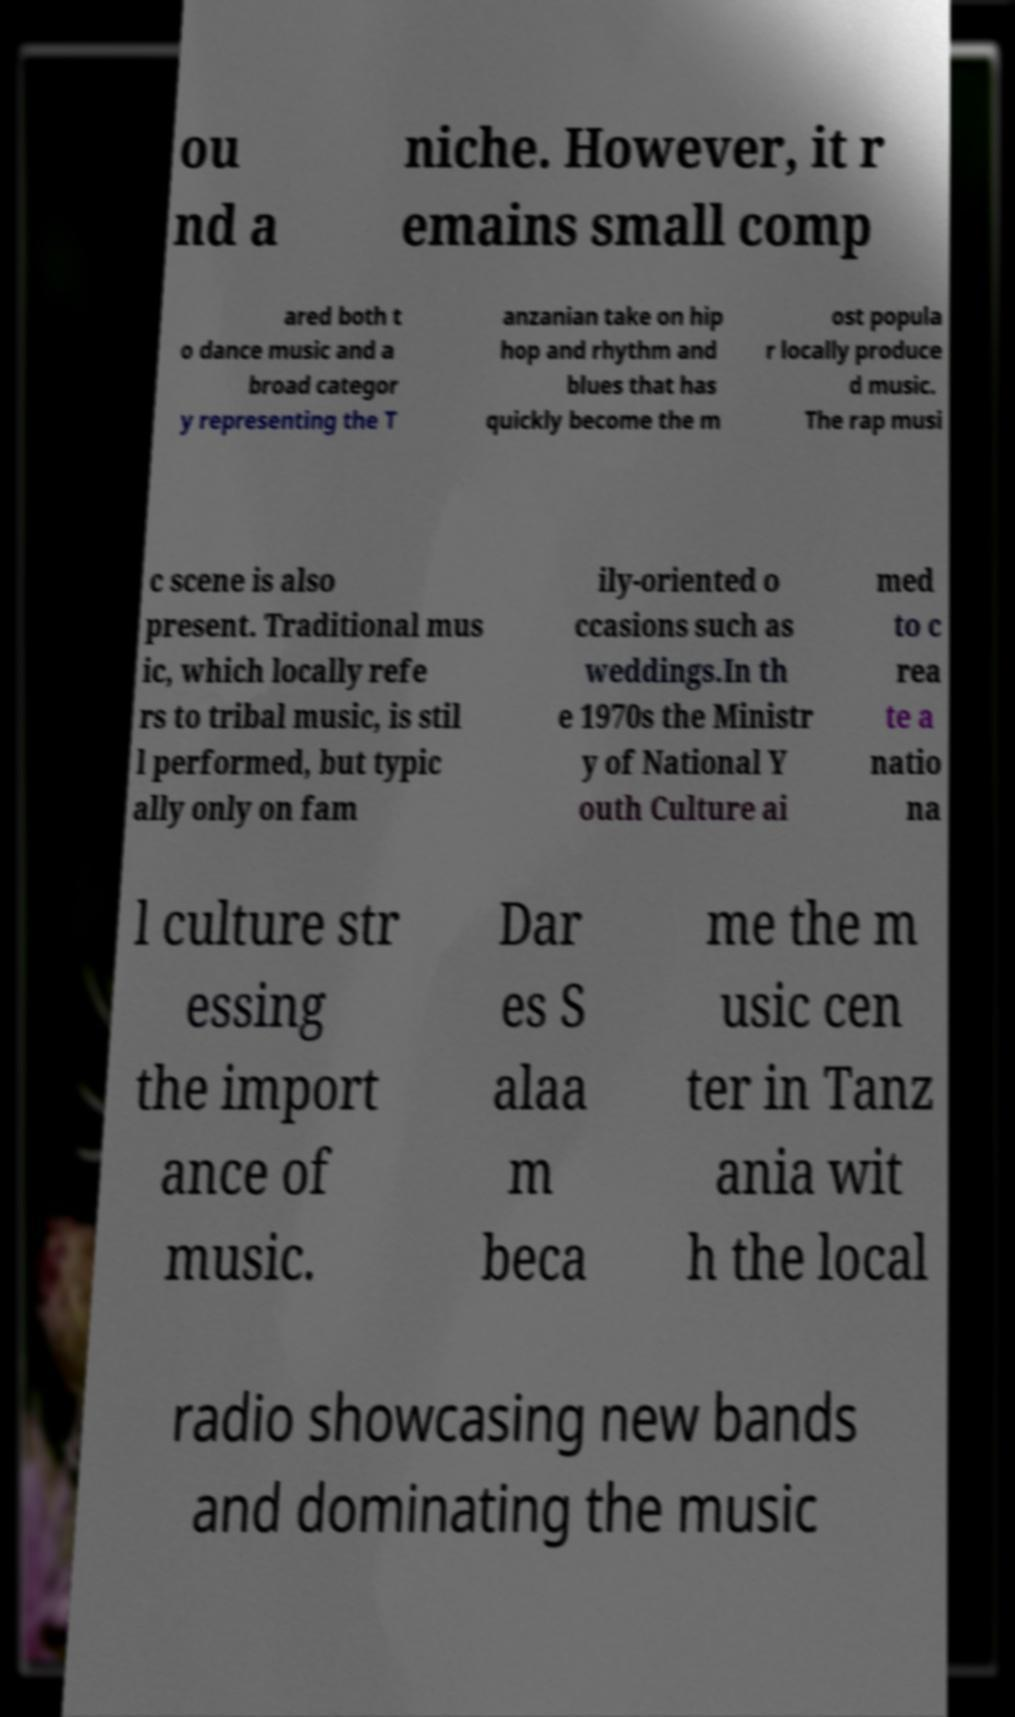There's text embedded in this image that I need extracted. Can you transcribe it verbatim? ou nd a niche. However, it r emains small comp ared both t o dance music and a broad categor y representing the T anzanian take on hip hop and rhythm and blues that has quickly become the m ost popula r locally produce d music. The rap musi c scene is also present. Traditional mus ic, which locally refe rs to tribal music, is stil l performed, but typic ally only on fam ily-oriented o ccasions such as weddings.In th e 1970s the Ministr y of National Y outh Culture ai med to c rea te a natio na l culture str essing the import ance of music. Dar es S alaa m beca me the m usic cen ter in Tanz ania wit h the local radio showcasing new bands and dominating the music 